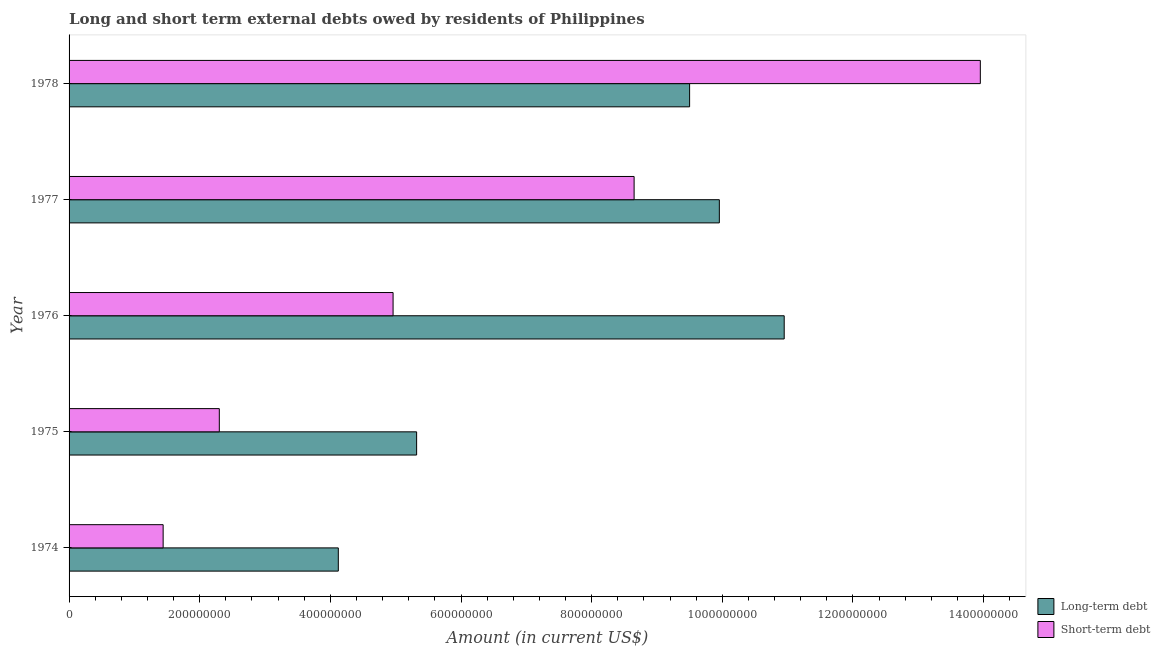Are the number of bars per tick equal to the number of legend labels?
Offer a terse response. Yes. How many bars are there on the 2nd tick from the bottom?
Make the answer very short. 2. What is the label of the 3rd group of bars from the top?
Ensure brevity in your answer.  1976. What is the short-term debts owed by residents in 1978?
Keep it short and to the point. 1.40e+09. Across all years, what is the maximum short-term debts owed by residents?
Give a very brief answer. 1.40e+09. Across all years, what is the minimum short-term debts owed by residents?
Keep it short and to the point. 1.44e+08. In which year was the short-term debts owed by residents maximum?
Your answer should be very brief. 1978. In which year was the long-term debts owed by residents minimum?
Your response must be concise. 1974. What is the total long-term debts owed by residents in the graph?
Make the answer very short. 3.98e+09. What is the difference between the short-term debts owed by residents in 1975 and that in 1978?
Make the answer very short. -1.16e+09. What is the difference between the short-term debts owed by residents in 1976 and the long-term debts owed by residents in 1974?
Your answer should be compact. 8.38e+07. What is the average long-term debts owed by residents per year?
Offer a very short reply. 7.97e+08. In the year 1978, what is the difference between the short-term debts owed by residents and long-term debts owed by residents?
Keep it short and to the point. 4.45e+08. What is the ratio of the long-term debts owed by residents in 1974 to that in 1975?
Make the answer very short. 0.78. What is the difference between the highest and the second highest short-term debts owed by residents?
Keep it short and to the point. 5.30e+08. What is the difference between the highest and the lowest long-term debts owed by residents?
Give a very brief answer. 6.83e+08. Is the sum of the short-term debts owed by residents in 1975 and 1978 greater than the maximum long-term debts owed by residents across all years?
Your answer should be compact. Yes. What does the 1st bar from the top in 1977 represents?
Provide a succinct answer. Short-term debt. What does the 1st bar from the bottom in 1977 represents?
Your response must be concise. Long-term debt. How many bars are there?
Make the answer very short. 10. Are all the bars in the graph horizontal?
Provide a short and direct response. Yes. How many years are there in the graph?
Keep it short and to the point. 5. What is the difference between two consecutive major ticks on the X-axis?
Provide a succinct answer. 2.00e+08. Does the graph contain any zero values?
Ensure brevity in your answer.  No. Does the graph contain grids?
Your answer should be very brief. No. How are the legend labels stacked?
Offer a terse response. Vertical. What is the title of the graph?
Provide a short and direct response. Long and short term external debts owed by residents of Philippines. Does "Male" appear as one of the legend labels in the graph?
Your answer should be very brief. No. What is the label or title of the X-axis?
Your answer should be compact. Amount (in current US$). What is the Amount (in current US$) in Long-term debt in 1974?
Provide a short and direct response. 4.12e+08. What is the Amount (in current US$) of Short-term debt in 1974?
Your answer should be very brief. 1.44e+08. What is the Amount (in current US$) in Long-term debt in 1975?
Offer a terse response. 5.32e+08. What is the Amount (in current US$) in Short-term debt in 1975?
Offer a very short reply. 2.30e+08. What is the Amount (in current US$) of Long-term debt in 1976?
Make the answer very short. 1.09e+09. What is the Amount (in current US$) of Short-term debt in 1976?
Your answer should be very brief. 4.96e+08. What is the Amount (in current US$) of Long-term debt in 1977?
Keep it short and to the point. 9.95e+08. What is the Amount (in current US$) of Short-term debt in 1977?
Provide a succinct answer. 8.65e+08. What is the Amount (in current US$) of Long-term debt in 1978?
Provide a short and direct response. 9.50e+08. What is the Amount (in current US$) of Short-term debt in 1978?
Provide a succinct answer. 1.40e+09. Across all years, what is the maximum Amount (in current US$) in Long-term debt?
Your answer should be very brief. 1.09e+09. Across all years, what is the maximum Amount (in current US$) in Short-term debt?
Offer a terse response. 1.40e+09. Across all years, what is the minimum Amount (in current US$) in Long-term debt?
Provide a short and direct response. 4.12e+08. Across all years, what is the minimum Amount (in current US$) of Short-term debt?
Keep it short and to the point. 1.44e+08. What is the total Amount (in current US$) of Long-term debt in the graph?
Your response must be concise. 3.98e+09. What is the total Amount (in current US$) of Short-term debt in the graph?
Ensure brevity in your answer.  3.13e+09. What is the difference between the Amount (in current US$) of Long-term debt in 1974 and that in 1975?
Your response must be concise. -1.20e+08. What is the difference between the Amount (in current US$) in Short-term debt in 1974 and that in 1975?
Offer a very short reply. -8.60e+07. What is the difference between the Amount (in current US$) of Long-term debt in 1974 and that in 1976?
Your response must be concise. -6.83e+08. What is the difference between the Amount (in current US$) of Short-term debt in 1974 and that in 1976?
Make the answer very short. -3.52e+08. What is the difference between the Amount (in current US$) in Long-term debt in 1974 and that in 1977?
Your answer should be very brief. -5.83e+08. What is the difference between the Amount (in current US$) in Short-term debt in 1974 and that in 1977?
Keep it short and to the point. -7.21e+08. What is the difference between the Amount (in current US$) of Long-term debt in 1974 and that in 1978?
Provide a short and direct response. -5.38e+08. What is the difference between the Amount (in current US$) in Short-term debt in 1974 and that in 1978?
Your answer should be compact. -1.25e+09. What is the difference between the Amount (in current US$) of Long-term debt in 1975 and that in 1976?
Offer a very short reply. -5.63e+08. What is the difference between the Amount (in current US$) of Short-term debt in 1975 and that in 1976?
Your answer should be compact. -2.66e+08. What is the difference between the Amount (in current US$) in Long-term debt in 1975 and that in 1977?
Your answer should be compact. -4.63e+08. What is the difference between the Amount (in current US$) of Short-term debt in 1975 and that in 1977?
Your answer should be compact. -6.35e+08. What is the difference between the Amount (in current US$) in Long-term debt in 1975 and that in 1978?
Provide a succinct answer. -4.18e+08. What is the difference between the Amount (in current US$) of Short-term debt in 1975 and that in 1978?
Give a very brief answer. -1.16e+09. What is the difference between the Amount (in current US$) in Long-term debt in 1976 and that in 1977?
Provide a short and direct response. 9.93e+07. What is the difference between the Amount (in current US$) in Short-term debt in 1976 and that in 1977?
Give a very brief answer. -3.69e+08. What is the difference between the Amount (in current US$) of Long-term debt in 1976 and that in 1978?
Make the answer very short. 1.45e+08. What is the difference between the Amount (in current US$) of Short-term debt in 1976 and that in 1978?
Your answer should be very brief. -8.99e+08. What is the difference between the Amount (in current US$) of Long-term debt in 1977 and that in 1978?
Provide a succinct answer. 4.55e+07. What is the difference between the Amount (in current US$) of Short-term debt in 1977 and that in 1978?
Give a very brief answer. -5.30e+08. What is the difference between the Amount (in current US$) of Long-term debt in 1974 and the Amount (in current US$) of Short-term debt in 1975?
Ensure brevity in your answer.  1.82e+08. What is the difference between the Amount (in current US$) of Long-term debt in 1974 and the Amount (in current US$) of Short-term debt in 1976?
Keep it short and to the point. -8.38e+07. What is the difference between the Amount (in current US$) of Long-term debt in 1974 and the Amount (in current US$) of Short-term debt in 1977?
Ensure brevity in your answer.  -4.53e+08. What is the difference between the Amount (in current US$) in Long-term debt in 1974 and the Amount (in current US$) in Short-term debt in 1978?
Offer a terse response. -9.83e+08. What is the difference between the Amount (in current US$) of Long-term debt in 1975 and the Amount (in current US$) of Short-term debt in 1976?
Your response must be concise. 3.61e+07. What is the difference between the Amount (in current US$) of Long-term debt in 1975 and the Amount (in current US$) of Short-term debt in 1977?
Give a very brief answer. -3.33e+08. What is the difference between the Amount (in current US$) in Long-term debt in 1975 and the Amount (in current US$) in Short-term debt in 1978?
Offer a very short reply. -8.63e+08. What is the difference between the Amount (in current US$) in Long-term debt in 1976 and the Amount (in current US$) in Short-term debt in 1977?
Offer a terse response. 2.30e+08. What is the difference between the Amount (in current US$) in Long-term debt in 1976 and the Amount (in current US$) in Short-term debt in 1978?
Keep it short and to the point. -3.00e+08. What is the difference between the Amount (in current US$) in Long-term debt in 1977 and the Amount (in current US$) in Short-term debt in 1978?
Offer a very short reply. -4.00e+08. What is the average Amount (in current US$) of Long-term debt per year?
Your response must be concise. 7.97e+08. What is the average Amount (in current US$) in Short-term debt per year?
Give a very brief answer. 6.26e+08. In the year 1974, what is the difference between the Amount (in current US$) of Long-term debt and Amount (in current US$) of Short-term debt?
Offer a terse response. 2.68e+08. In the year 1975, what is the difference between the Amount (in current US$) in Long-term debt and Amount (in current US$) in Short-term debt?
Provide a short and direct response. 3.02e+08. In the year 1976, what is the difference between the Amount (in current US$) of Long-term debt and Amount (in current US$) of Short-term debt?
Provide a short and direct response. 5.99e+08. In the year 1977, what is the difference between the Amount (in current US$) of Long-term debt and Amount (in current US$) of Short-term debt?
Offer a terse response. 1.30e+08. In the year 1978, what is the difference between the Amount (in current US$) of Long-term debt and Amount (in current US$) of Short-term debt?
Your answer should be compact. -4.45e+08. What is the ratio of the Amount (in current US$) of Long-term debt in 1974 to that in 1975?
Give a very brief answer. 0.77. What is the ratio of the Amount (in current US$) of Short-term debt in 1974 to that in 1975?
Offer a very short reply. 0.63. What is the ratio of the Amount (in current US$) in Long-term debt in 1974 to that in 1976?
Provide a succinct answer. 0.38. What is the ratio of the Amount (in current US$) of Short-term debt in 1974 to that in 1976?
Provide a succinct answer. 0.29. What is the ratio of the Amount (in current US$) of Long-term debt in 1974 to that in 1977?
Make the answer very short. 0.41. What is the ratio of the Amount (in current US$) of Short-term debt in 1974 to that in 1977?
Give a very brief answer. 0.17. What is the ratio of the Amount (in current US$) in Long-term debt in 1974 to that in 1978?
Make the answer very short. 0.43. What is the ratio of the Amount (in current US$) in Short-term debt in 1974 to that in 1978?
Ensure brevity in your answer.  0.1. What is the ratio of the Amount (in current US$) of Long-term debt in 1975 to that in 1976?
Provide a succinct answer. 0.49. What is the ratio of the Amount (in current US$) in Short-term debt in 1975 to that in 1976?
Your answer should be very brief. 0.46. What is the ratio of the Amount (in current US$) of Long-term debt in 1975 to that in 1977?
Ensure brevity in your answer.  0.53. What is the ratio of the Amount (in current US$) of Short-term debt in 1975 to that in 1977?
Give a very brief answer. 0.27. What is the ratio of the Amount (in current US$) in Long-term debt in 1975 to that in 1978?
Your response must be concise. 0.56. What is the ratio of the Amount (in current US$) of Short-term debt in 1975 to that in 1978?
Your answer should be very brief. 0.16. What is the ratio of the Amount (in current US$) in Long-term debt in 1976 to that in 1977?
Give a very brief answer. 1.1. What is the ratio of the Amount (in current US$) in Short-term debt in 1976 to that in 1977?
Your answer should be compact. 0.57. What is the ratio of the Amount (in current US$) in Long-term debt in 1976 to that in 1978?
Give a very brief answer. 1.15. What is the ratio of the Amount (in current US$) in Short-term debt in 1976 to that in 1978?
Provide a short and direct response. 0.36. What is the ratio of the Amount (in current US$) in Long-term debt in 1977 to that in 1978?
Give a very brief answer. 1.05. What is the ratio of the Amount (in current US$) of Short-term debt in 1977 to that in 1978?
Your answer should be very brief. 0.62. What is the difference between the highest and the second highest Amount (in current US$) of Long-term debt?
Offer a terse response. 9.93e+07. What is the difference between the highest and the second highest Amount (in current US$) in Short-term debt?
Your answer should be compact. 5.30e+08. What is the difference between the highest and the lowest Amount (in current US$) in Long-term debt?
Offer a terse response. 6.83e+08. What is the difference between the highest and the lowest Amount (in current US$) in Short-term debt?
Give a very brief answer. 1.25e+09. 